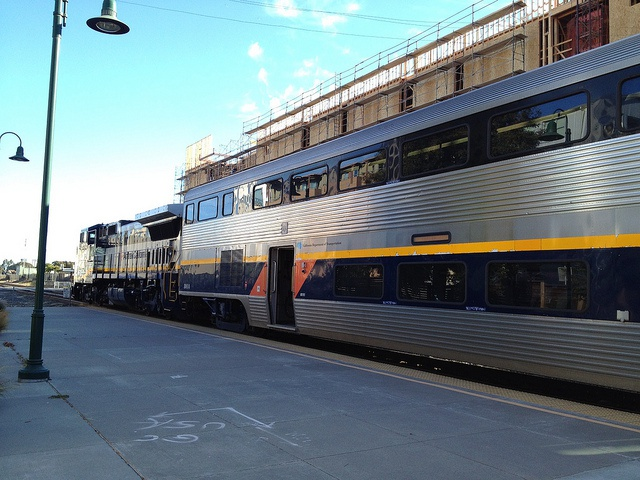Describe the objects in this image and their specific colors. I can see a train in lightblue, black, gray, and darkgray tones in this image. 